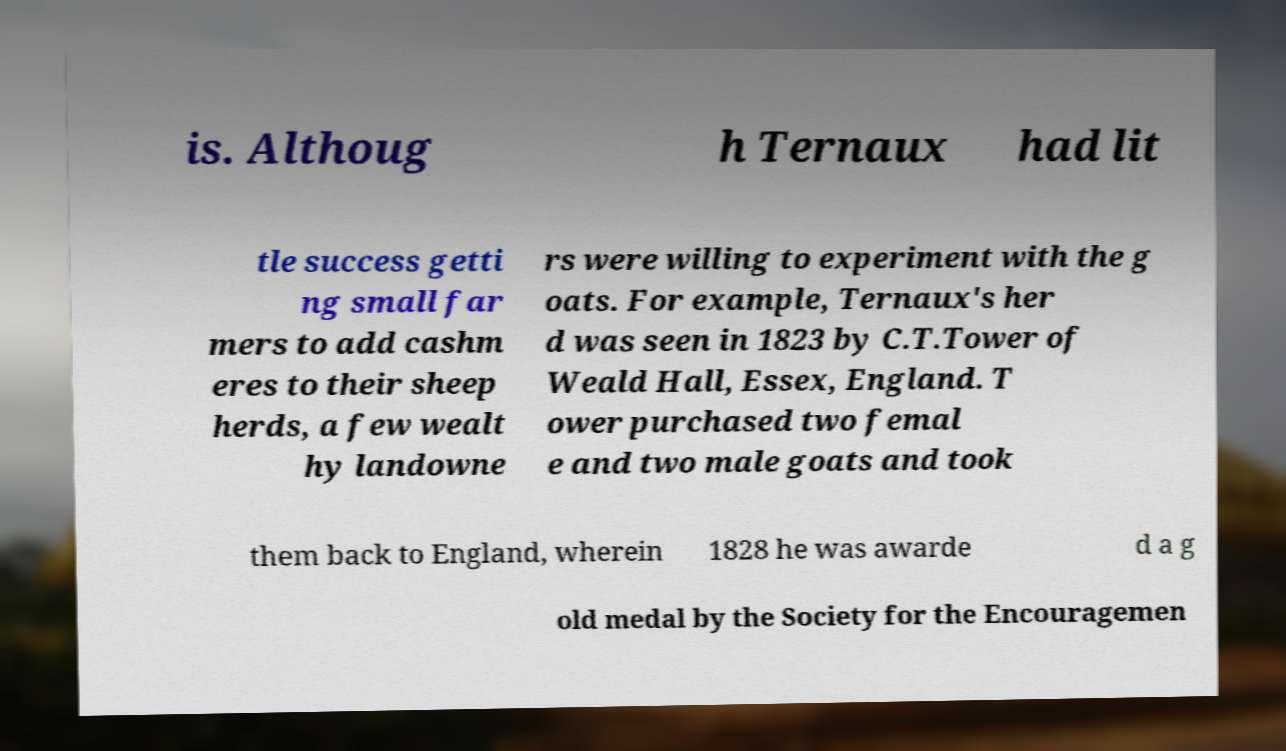Could you assist in decoding the text presented in this image and type it out clearly? is. Althoug h Ternaux had lit tle success getti ng small far mers to add cashm eres to their sheep herds, a few wealt hy landowne rs were willing to experiment with the g oats. For example, Ternaux's her d was seen in 1823 by C.T.Tower of Weald Hall, Essex, England. T ower purchased two femal e and two male goats and took them back to England, wherein 1828 he was awarde d a g old medal by the Society for the Encouragemen 